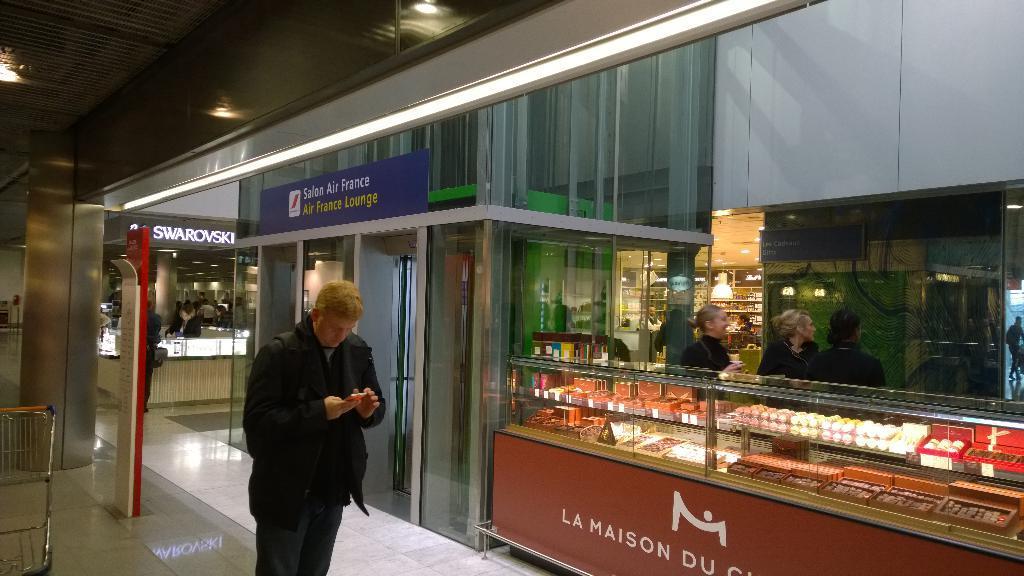How would you summarize this image in a sentence or two? In this picture we can see a man standing and holding a mobile with his hands, trolley, some objects in racks, lights and in the background we can see a group of people. 